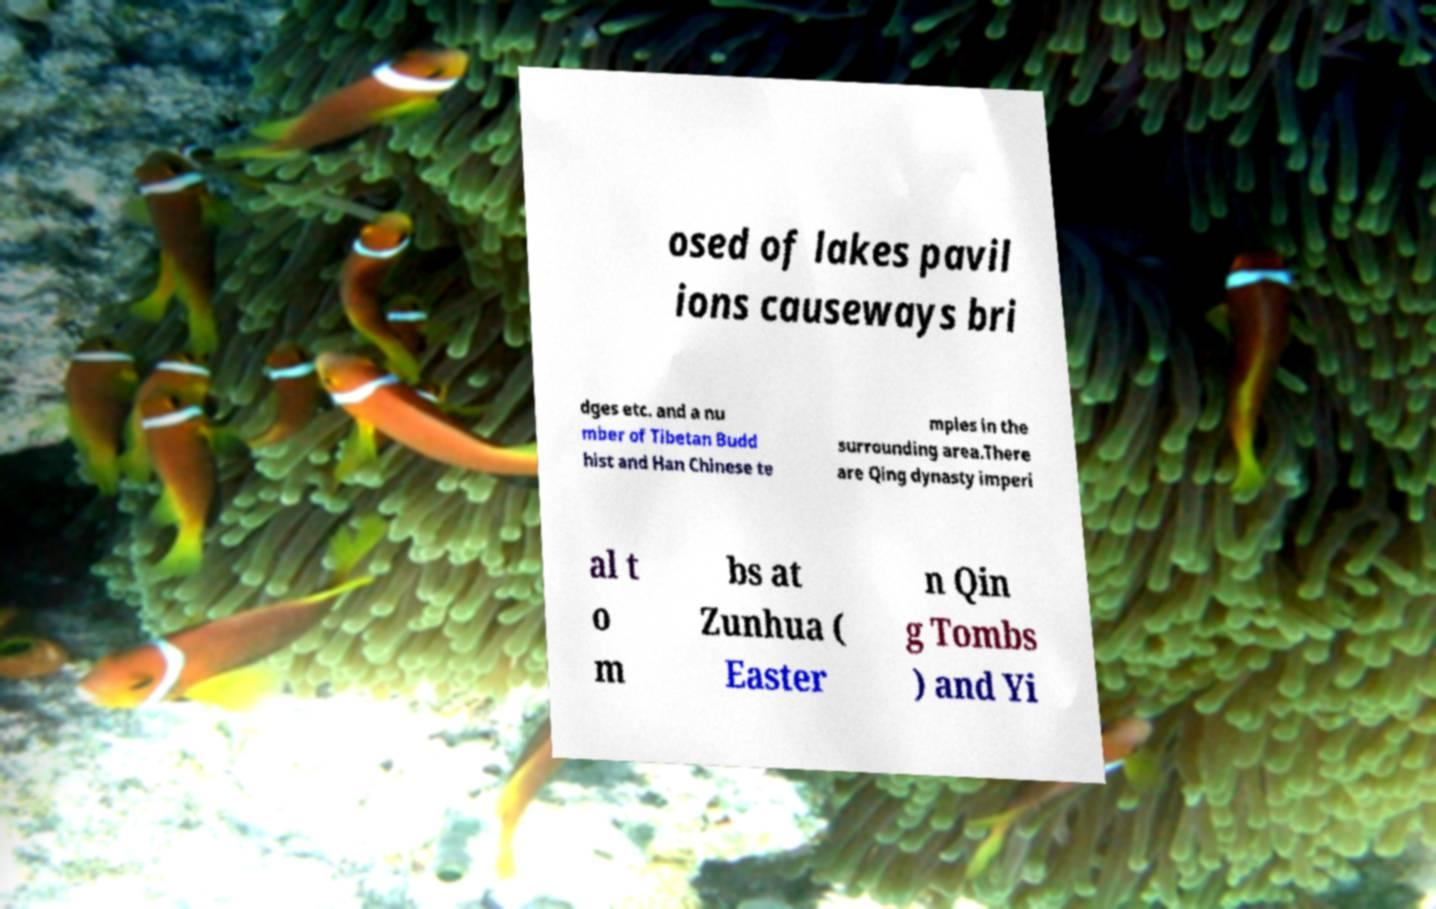Can you accurately transcribe the text from the provided image for me? osed of lakes pavil ions causeways bri dges etc. and a nu mber of Tibetan Budd hist and Han Chinese te mples in the surrounding area.There are Qing dynasty imperi al t o m bs at Zunhua ( Easter n Qin g Tombs ) and Yi 